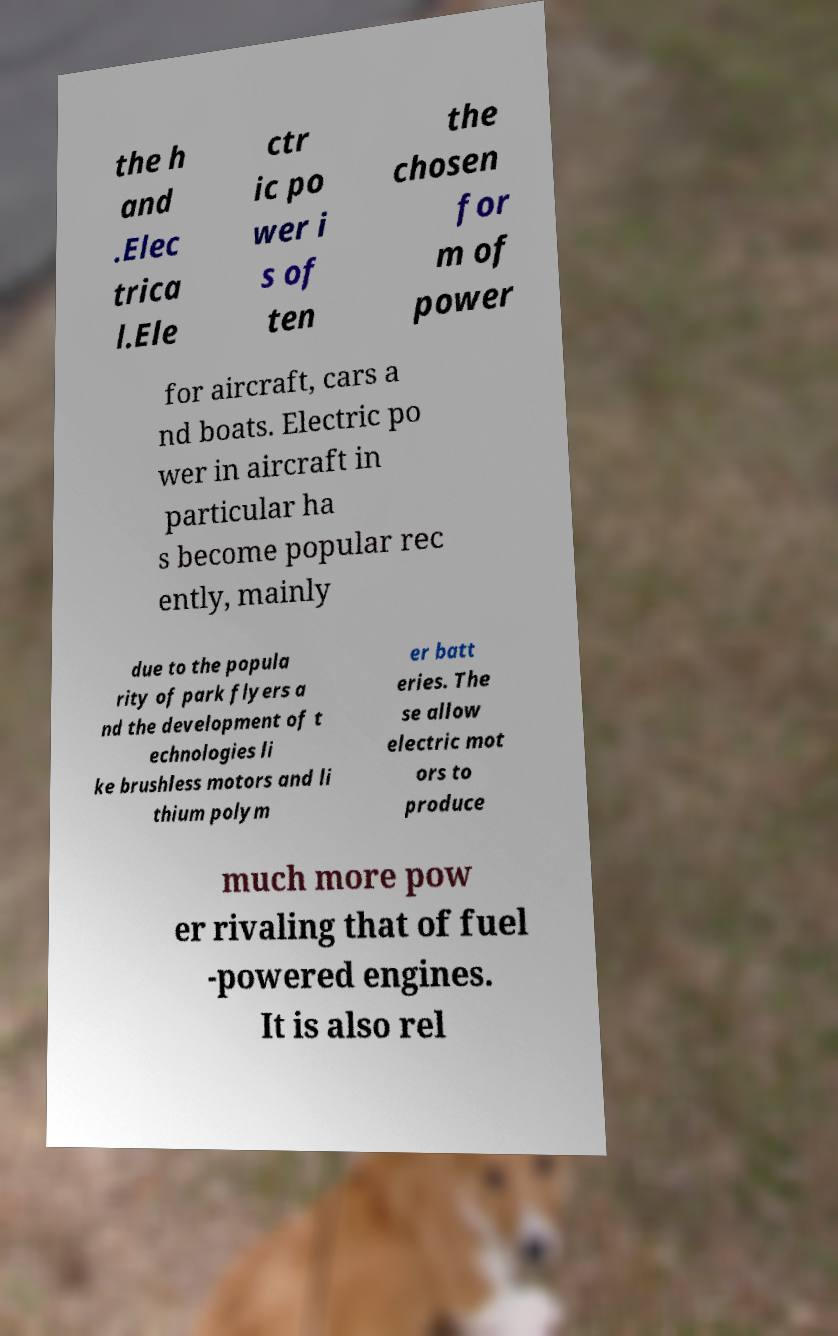Can you read and provide the text displayed in the image?This photo seems to have some interesting text. Can you extract and type it out for me? the h and .Elec trica l.Ele ctr ic po wer i s of ten the chosen for m of power for aircraft, cars a nd boats. Electric po wer in aircraft in particular ha s become popular rec ently, mainly due to the popula rity of park flyers a nd the development of t echnologies li ke brushless motors and li thium polym er batt eries. The se allow electric mot ors to produce much more pow er rivaling that of fuel -powered engines. It is also rel 